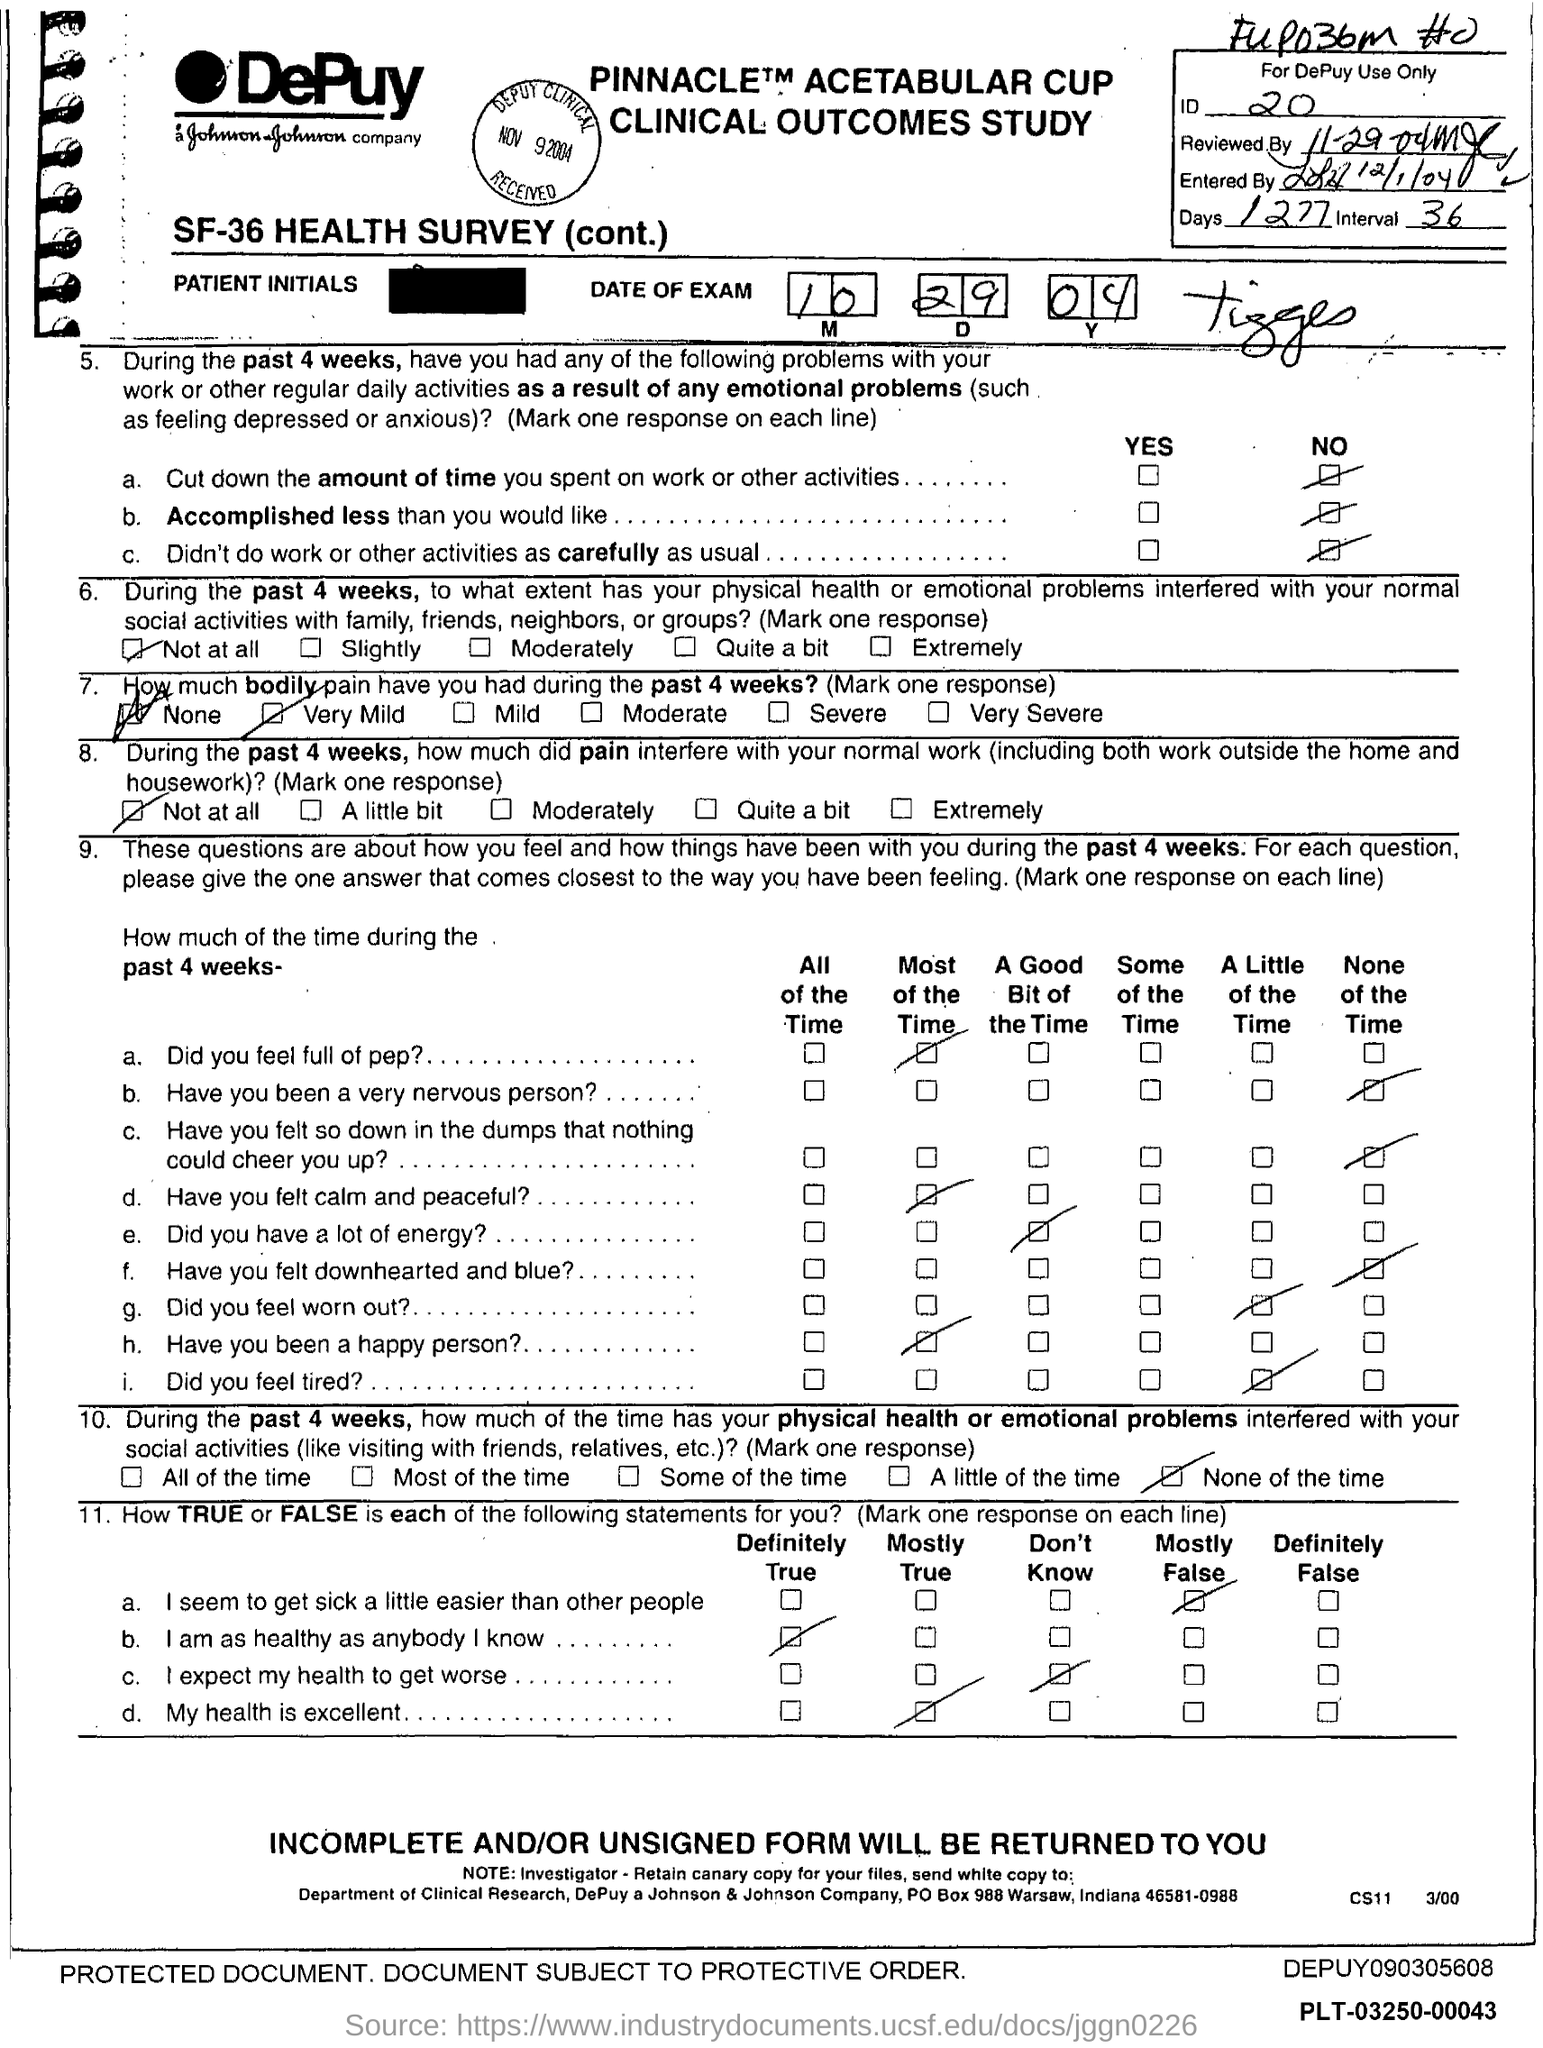What is the ID number?
Provide a succinct answer. 20. Which city is the DePuy company in?
Give a very brief answer. Warsaw. What is the number of days mentioned on the top right corner?
Keep it short and to the point. 1277. 